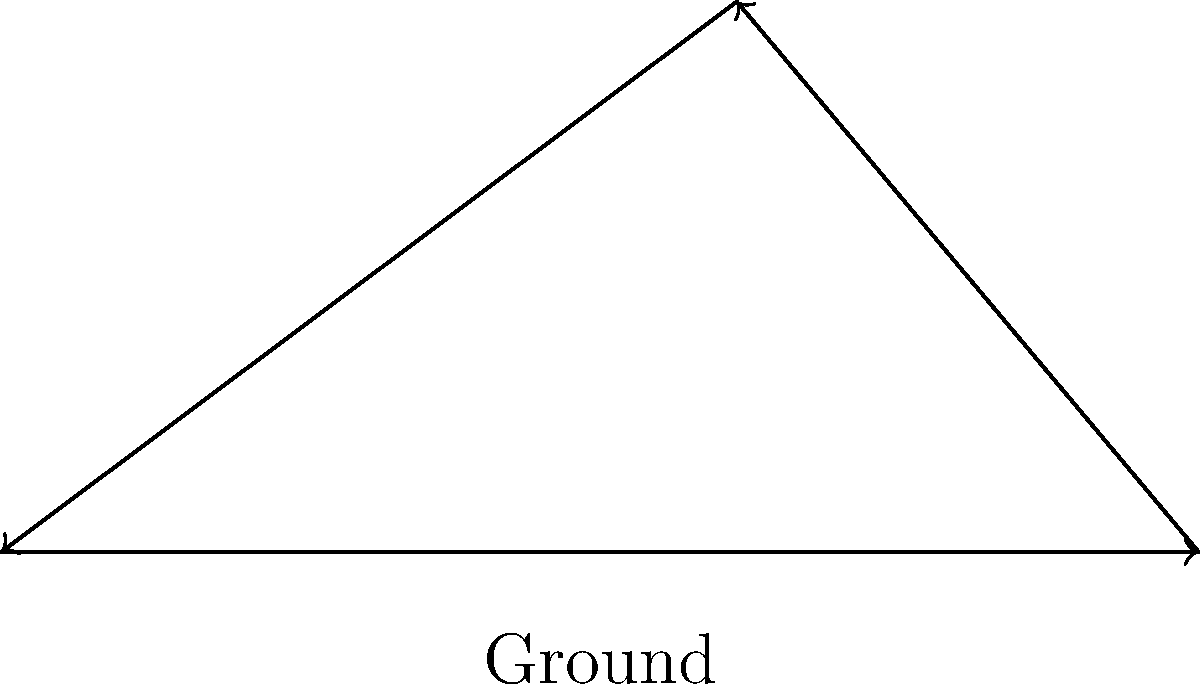As a hermit's cousin familiar with off-grid living, you're helping design a solar panel system for your relative's shelter. Given that the optimal angle $\theta$ for solar panel placement is equal to the shelter's latitude, what would be the ideal angle for positioning the panels if the hermit's shelter is located at 50°N latitude? To determine the optimal angle for positioning solar panels on a hermit's shelter, we need to consider the following steps:

1. Understand the relationship between latitude and optimal solar panel angle:
   The general rule of thumb is that the optimal tilt angle for fixed solar panels is approximately equal to the latitude of the location.

2. Identify the latitude of the hermit's shelter:
   In this case, the shelter is located at 50°N latitude.

3. Apply the rule:
   Since the optimal angle $\theta$ is equal to the latitude, we can directly use the given latitude as the ideal angle for positioning the solar panels.

4. Consider seasonal adjustments:
   While not required for this question, it's worth noting that some systems adjust the angle seasonally:
   - Winter: latitude + 15°
   - Summer: latitude - 15°

5. Conclude:
   For a shelter at 50°N latitude, the optimal fixed angle for the solar panels would be 50°.

This angle ensures that the solar panels receive the maximum amount of direct sunlight throughout the year, optimizing energy production for the hermit's self-sufficient lifestyle.
Answer: 50° 